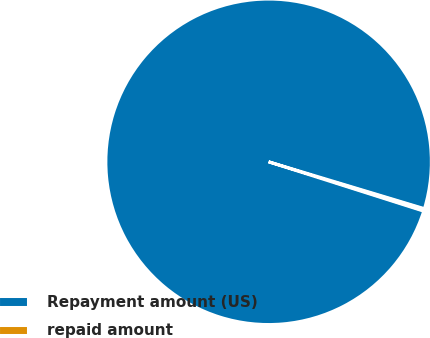Convert chart to OTSL. <chart><loc_0><loc_0><loc_500><loc_500><pie_chart><fcel>Repayment amount (US)<fcel>repaid amount<nl><fcel>99.75%<fcel>0.25%<nl></chart> 